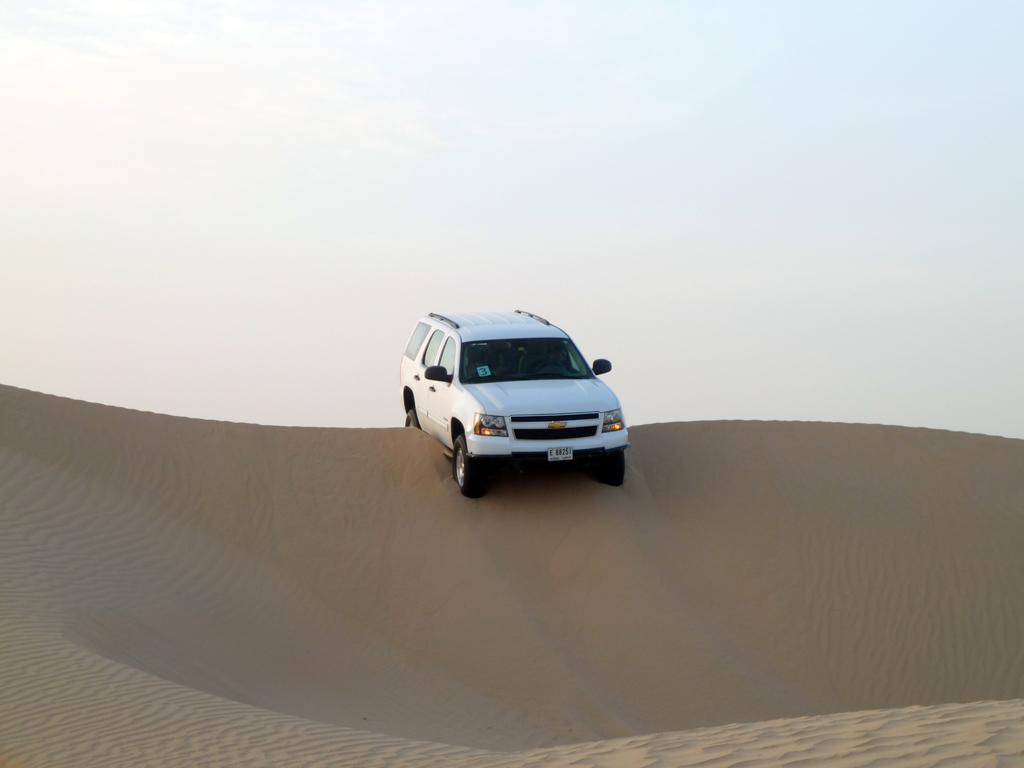Could you give a brief overview of what you see in this image? In this picture I can see a car in the middle, at the bottom there is the sand. At the top I can see the sky. 